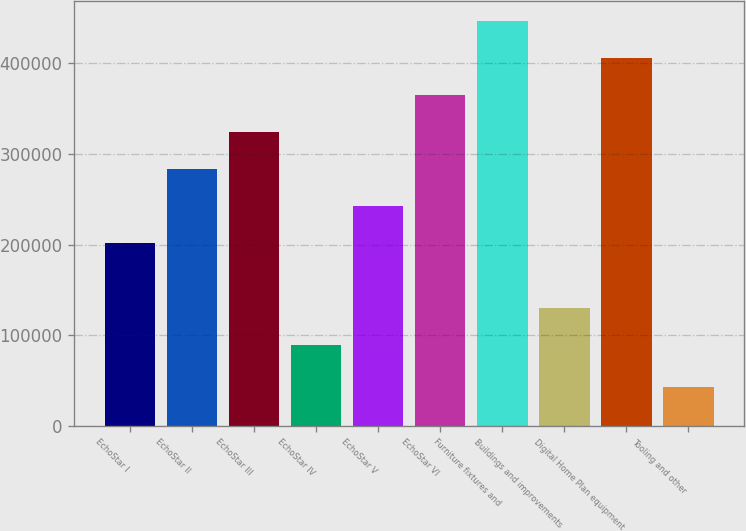Convert chart. <chart><loc_0><loc_0><loc_500><loc_500><bar_chart><fcel>EchoStar I<fcel>EchoStar II<fcel>EchoStar III<fcel>EchoStar IV<fcel>EchoStar V<fcel>EchoStar VI<fcel>Furniture fixtures and<fcel>Buildings and improvements<fcel>Digital Home Plan equipment<fcel>Tooling and other<nl><fcel>201607<fcel>283193<fcel>323985<fcel>89505<fcel>242400<fcel>364778<fcel>446364<fcel>130298<fcel>405571<fcel>42387.8<nl></chart> 